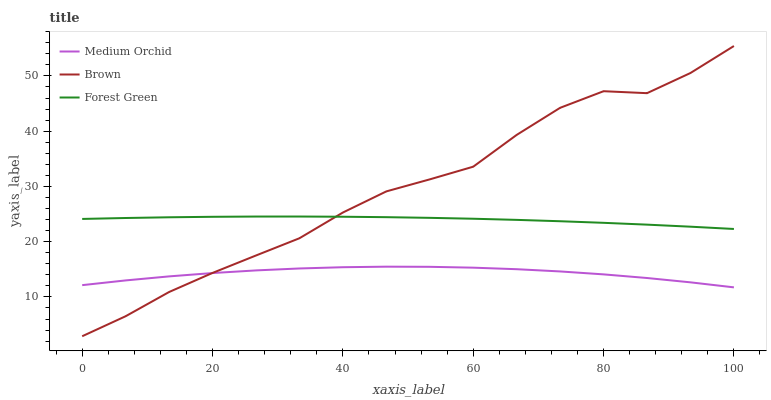Does Medium Orchid have the minimum area under the curve?
Answer yes or no. Yes. Does Brown have the maximum area under the curve?
Answer yes or no. Yes. Does Forest Green have the minimum area under the curve?
Answer yes or no. No. Does Forest Green have the maximum area under the curve?
Answer yes or no. No. Is Forest Green the smoothest?
Answer yes or no. Yes. Is Brown the roughest?
Answer yes or no. Yes. Is Medium Orchid the smoothest?
Answer yes or no. No. Is Medium Orchid the roughest?
Answer yes or no. No. Does Brown have the lowest value?
Answer yes or no. Yes. Does Medium Orchid have the lowest value?
Answer yes or no. No. Does Brown have the highest value?
Answer yes or no. Yes. Does Forest Green have the highest value?
Answer yes or no. No. Is Medium Orchid less than Forest Green?
Answer yes or no. Yes. Is Forest Green greater than Medium Orchid?
Answer yes or no. Yes. Does Medium Orchid intersect Brown?
Answer yes or no. Yes. Is Medium Orchid less than Brown?
Answer yes or no. No. Is Medium Orchid greater than Brown?
Answer yes or no. No. Does Medium Orchid intersect Forest Green?
Answer yes or no. No. 